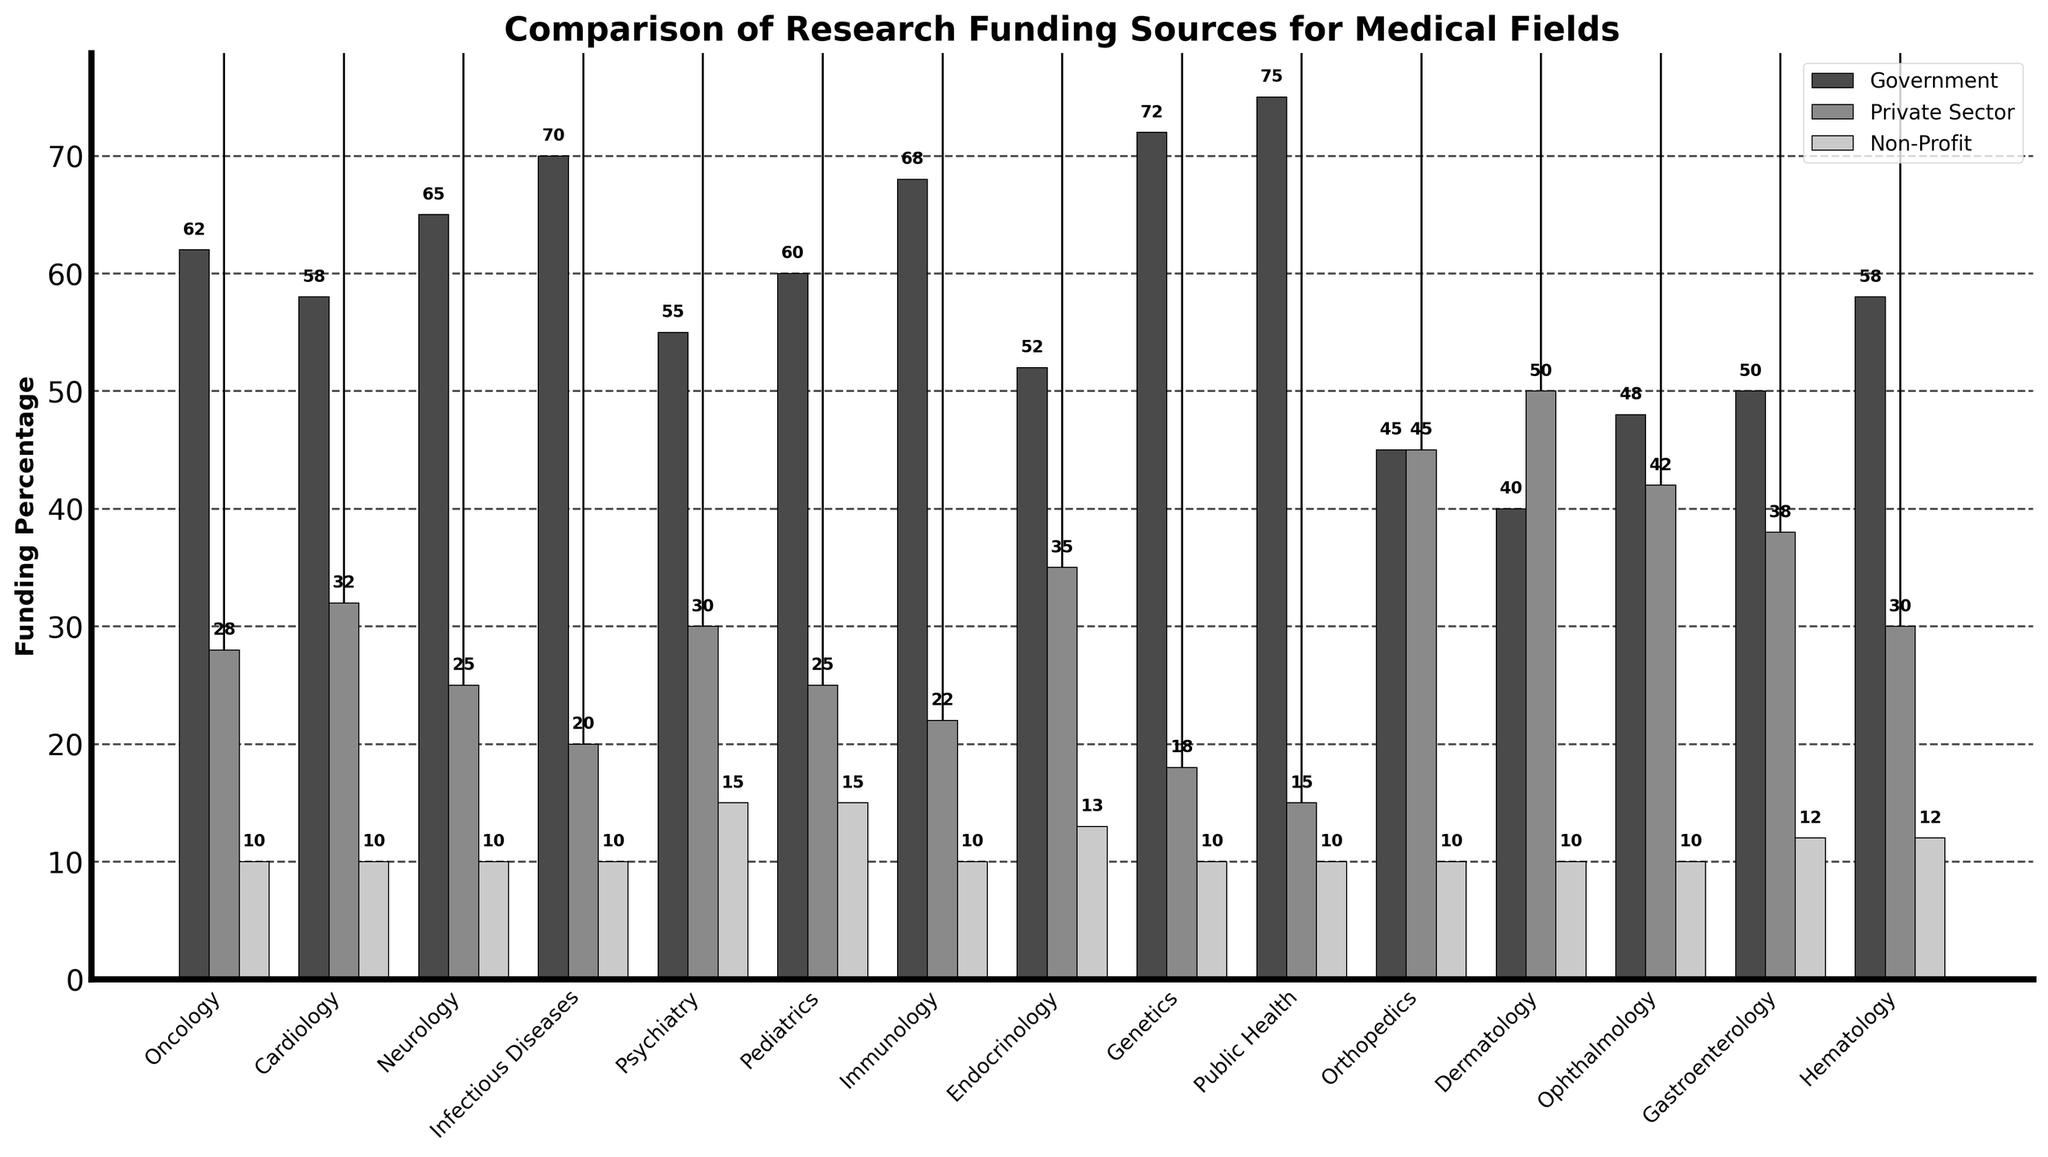Which medical field receives the highest percentage of government funding? Look for the tallest bar in the "Government" category. The field with the tallest bar in this category is Public Health at 75%.
Answer: Public Health Which medical field has the highest percentage of private sector funding? Look for the tallest bar in the "Private Sector" category. The field with the tallest bar in this category is Dermatology at 50%.
Answer: Dermatology Which medical field receives an equal proportion of funding from government and private sectors? Identify the field where the heights of the government and private sector bars are the same. The field with equal funding is Orthopedics, both at 45%.
Answer: Orthopedics What's the combined percentage of government and non-profit funding for Cardiology? Find the government and non-profit funding percentages for Cardiology and add them. Government funding is 58% and non-profit funding is 10%, so the combined percentage is 58% + 10% = 68%.
Answer: 68% Which medical field has the lowest government funding? Look for the shortest bar in the "Government" category. The field with the shortest bar is Dermatology at 40%.
Answer: Dermatology Compare the funding from the private sector for Ophthalmology and Gastroenterology. Which receives more, and by how much? Find the private sector funding percentages for both fields. Ophthalmology has 42% and Gastroenterology has 38%. The difference is 42% - 38% = 4%.
Answer: Ophthalmology, by 4% In which medical field is the difference between government and private sector funding the greatest? Calculate the differences for each field and determine the greatest difference. Genetics has the greatest difference with government funding at 72% and private sector funding at 18%. The difference is 72% - 18% = 54%.
Answer: Genetics Which fields receive 10% non-profit funding? Identify the fields where the bar corresponding to non-profit funding reaches the 10% mark. The fields are Oncology, Cardiology, Neurology, Infectious Diseases, Immunology, Genetics, Ophthalmology, and Dermatology.
Answer: Oncology, Cardiology, Neurology, Infectious Diseases, Immunology, Genetics, Ophthalmology, Dermatology What is the average private sector funding across all medical fields? Sum up all private sector funding percentages and divide by the number of fields. The total sum is 445%, and there are 15 fields, so the average is 445% / 15 ≈ 29.67%.
Answer: 29.67% Find the difference in government funding between Oncology and Psychiatry. Government funding for Oncology is 62% and for Psychiatry is 55%. The difference is 62% - 55% = 7%.
Answer: 7% 